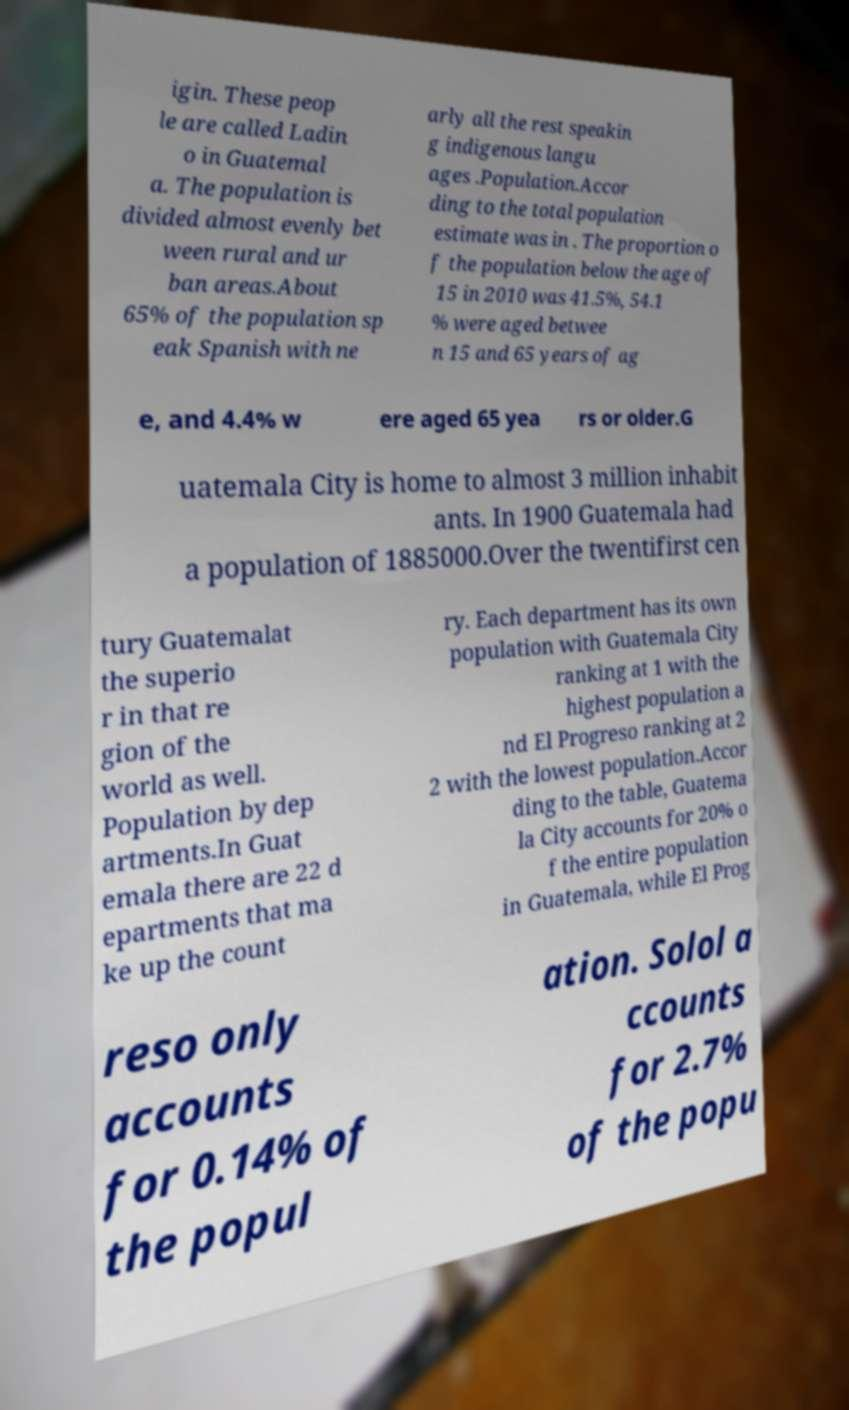Please identify and transcribe the text found in this image. igin. These peop le are called Ladin o in Guatemal a. The population is divided almost evenly bet ween rural and ur ban areas.About 65% of the population sp eak Spanish with ne arly all the rest speakin g indigenous langu ages .Population.Accor ding to the total population estimate was in . The proportion o f the population below the age of 15 in 2010 was 41.5%, 54.1 % were aged betwee n 15 and 65 years of ag e, and 4.4% w ere aged 65 yea rs or older.G uatemala City is home to almost 3 million inhabit ants. In 1900 Guatemala had a population of 1885000.Over the twentifirst cen tury Guatemalat the superio r in that re gion of the world as well. Population by dep artments.In Guat emala there are 22 d epartments that ma ke up the count ry. Each department has its own population with Guatemala City ranking at 1 with the highest population a nd El Progreso ranking at 2 2 with the lowest population.Accor ding to the table, Guatema la City accounts for 20% o f the entire population in Guatemala, while El Prog reso only accounts for 0.14% of the popul ation. Solol a ccounts for 2.7% of the popu 